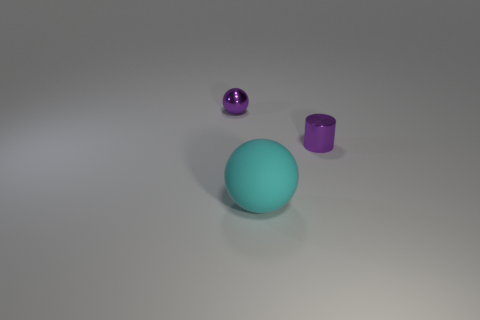What is the size of the cyan rubber sphere?
Your response must be concise. Large. Are there more purple cylinders in front of the large cyan thing than small yellow rubber things?
Offer a very short reply. No. Are there an equal number of big rubber objects that are in front of the tiny purple ball and purple cylinders in front of the cyan object?
Ensure brevity in your answer.  No. There is a object that is both in front of the metallic sphere and behind the big matte ball; what is its color?
Your response must be concise. Purple. Is there anything else that is the same size as the shiny cylinder?
Give a very brief answer. Yes. Is the number of cylinders that are on the left side of the cyan sphere greater than the number of small purple metallic cylinders that are behind the small purple metal ball?
Provide a succinct answer. No. Do the purple metallic object to the right of the purple sphere and the cyan rubber sphere have the same size?
Keep it short and to the point. No. There is a object behind the purple shiny thing on the right side of the big thing; how many shiny spheres are in front of it?
Make the answer very short. 0. There is a thing that is both behind the cyan rubber ball and to the left of the purple cylinder; what size is it?
Your response must be concise. Small. What number of other things are the same shape as the cyan rubber thing?
Offer a terse response. 1. 